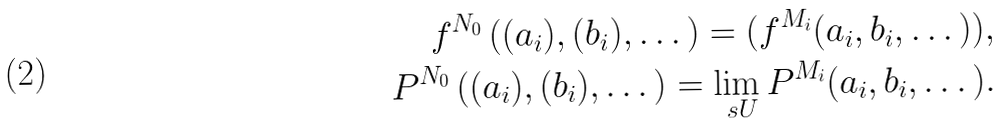Convert formula to latex. <formula><loc_0><loc_0><loc_500><loc_500>f ^ { N _ { 0 } } \left ( ( a _ { i } ) , ( b _ { i } ) , \dots \right ) = ( f ^ { M _ { i } } ( a _ { i } , b _ { i } , \dots ) ) , \\ P ^ { N _ { 0 } } \left ( ( a _ { i } ) , ( b _ { i } ) , \dots \right ) = \lim _ { \ s U } P ^ { M _ { i } } ( a _ { i } , b _ { i } , \dots ) .</formula> 